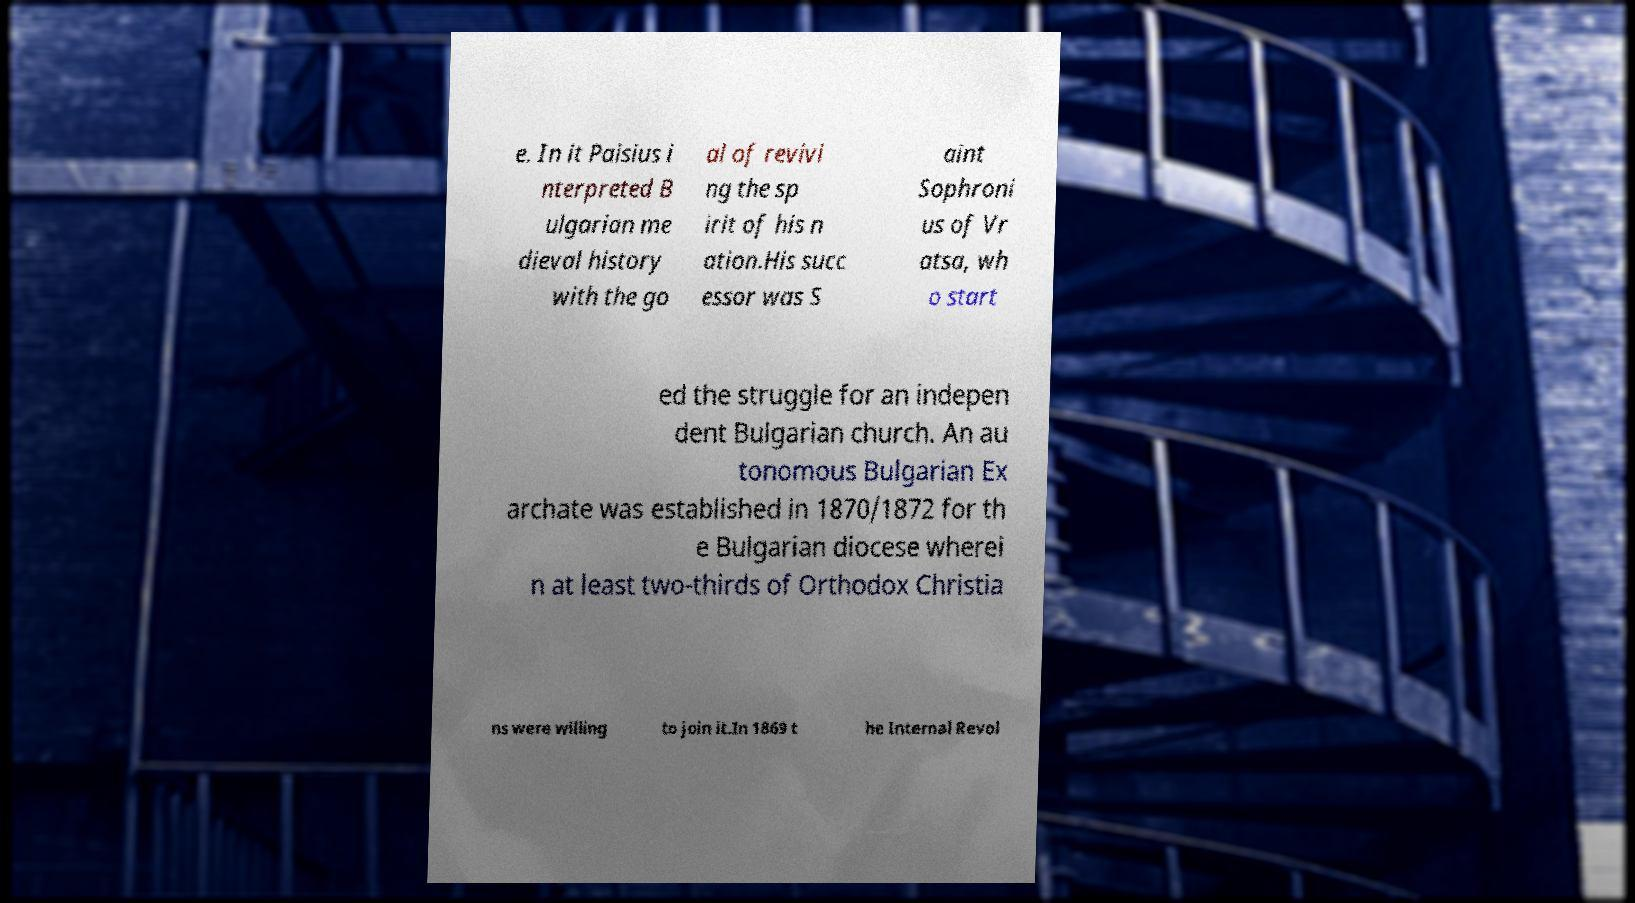Could you extract and type out the text from this image? e. In it Paisius i nterpreted B ulgarian me dieval history with the go al of revivi ng the sp irit of his n ation.His succ essor was S aint Sophroni us of Vr atsa, wh o start ed the struggle for an indepen dent Bulgarian church. An au tonomous Bulgarian Ex archate was established in 1870/1872 for th e Bulgarian diocese wherei n at least two-thirds of Orthodox Christia ns were willing to join it.In 1869 t he Internal Revol 